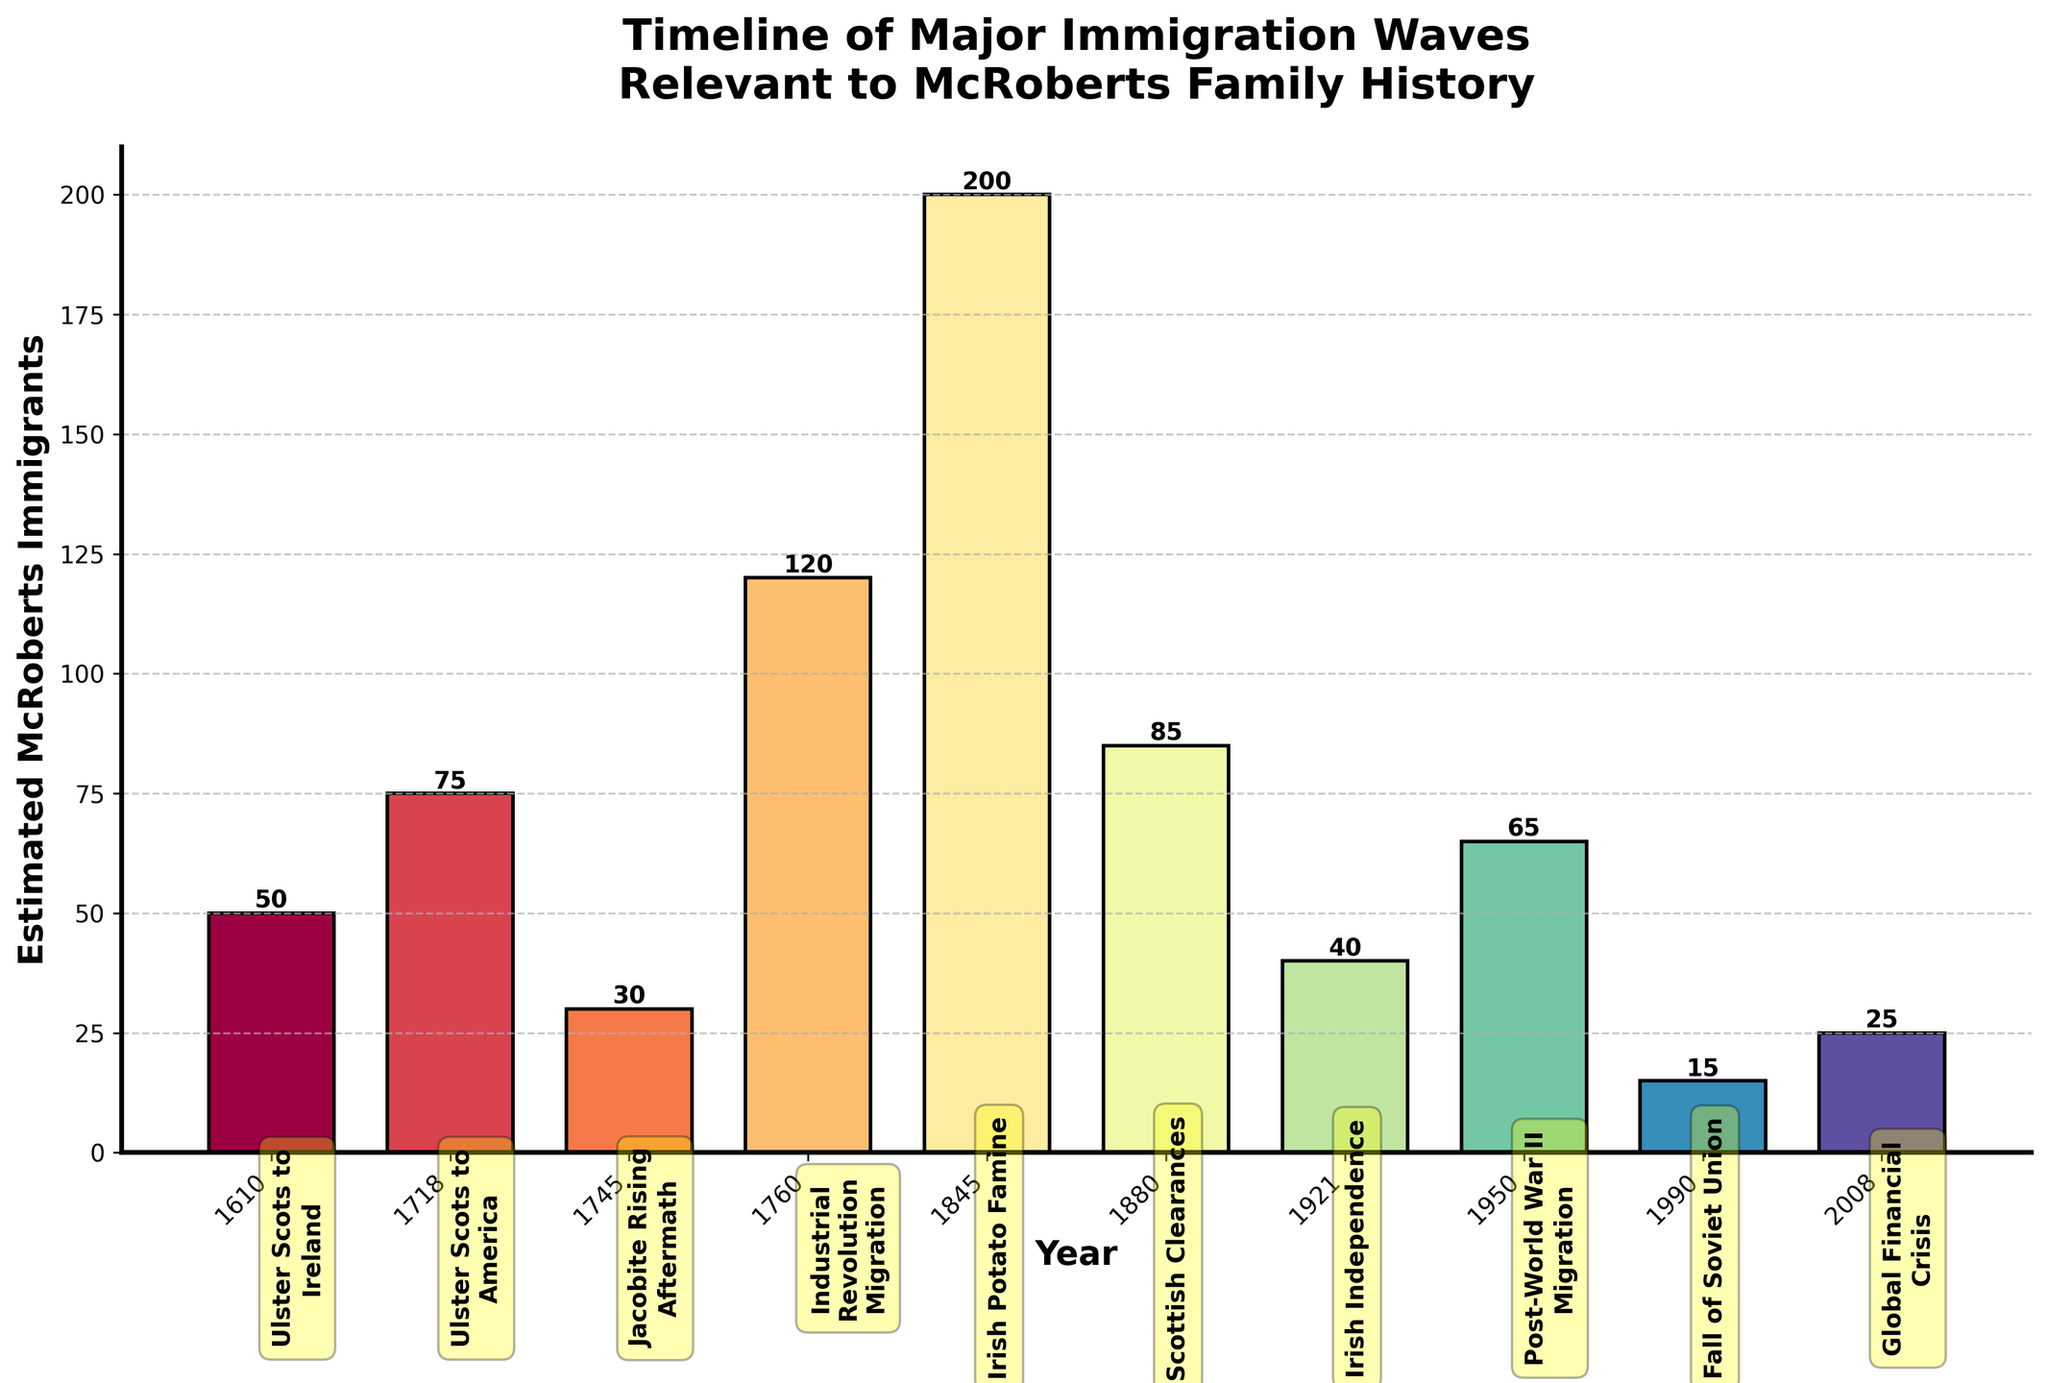Which immigration wave had the highest number of estimated McRoberts immigrants? By looking at the heights of the bars, we can see that the bar for the year 1845 (Irish Potato Famine) is the tallest, indicating the highest estimate of McRoberts immigrants.
Answer: Irish Potato Famine What is the sum of estimated McRoberts immigrants during the 18th century (1700s)? The 18th-century immigration waves are in 1718 and 1745. Add the values for these years: 75 (1718) + 30 (1745) = 105.
Answer: 105 Which immigration wave had fewer estimated McRoberts immigrants: Post-World War II Migration or the Fall of the Soviet Union? Post-World War II Migration is 1950 with 65 immigrants and the Fall of the Soviet Union is 1990 with 15 immigrants. 15 < 65, so the Fall of the Soviet Union had fewer immigrants.
Answer: Fall of the Soviet Union What is the difference in the number of estimated McRoberts immigrants between the Irish Potato Famine and the Global Financial Crisis waves? The Irish Potato Famine (1845) has 200 immigrants and the Global Financial Crisis (2008) has 25 immigrants. The difference is 200 - 25 = 175.
Answer: 175 In which century did more immigration waves relevant to the McRoberts family occur, the 18th century (1700s) or the 20th century (1900s)? The 18th century (1700s) had 2 waves: 1718, 1745. The 20th century (1900s) had 3 waves: 1921, 1950, 1990. Since 3 > 2, more immigration waves occurred in the 20th century.
Answer: 20th century What's the average number of estimated McRoberts immigrants across all the listed waves? Sum of all immigrants is 50 + 75 + 30 + 120 + 200 + 85 + 40 + 65 + 15 + 25 = 705. There are 10 data points, so the average is 705 / 10 = 70.5.
Answer: 70.5 Which bar is colored differently to indicate a different wave? Each bar is colored uniquely to distinguish different immigration waves. No specific wave stands out in color relative to others.
Answer: Each bar is unique What is the trend in estimated McRoberts immigrants from 1950 to 2008? From 1950 (Post-World War II Migration) to 2008 (Global Financial Crisis), the number of estimated immigrants is 65 (1950), 15 (1990), 25 (2008), showing a decreasing trend followed by a slight increase.
Answer: Decrease, then slight increase What is the average number of estimated McRoberts immigrants during the 20th century? The 20th-century waves are in 1921 (40), 1950 (65), and 1990 (15). Sum these values: 40 + 65 + 15 = 120. There are 3 data points. The average is 120 / 3 = 40.
Answer: 40 